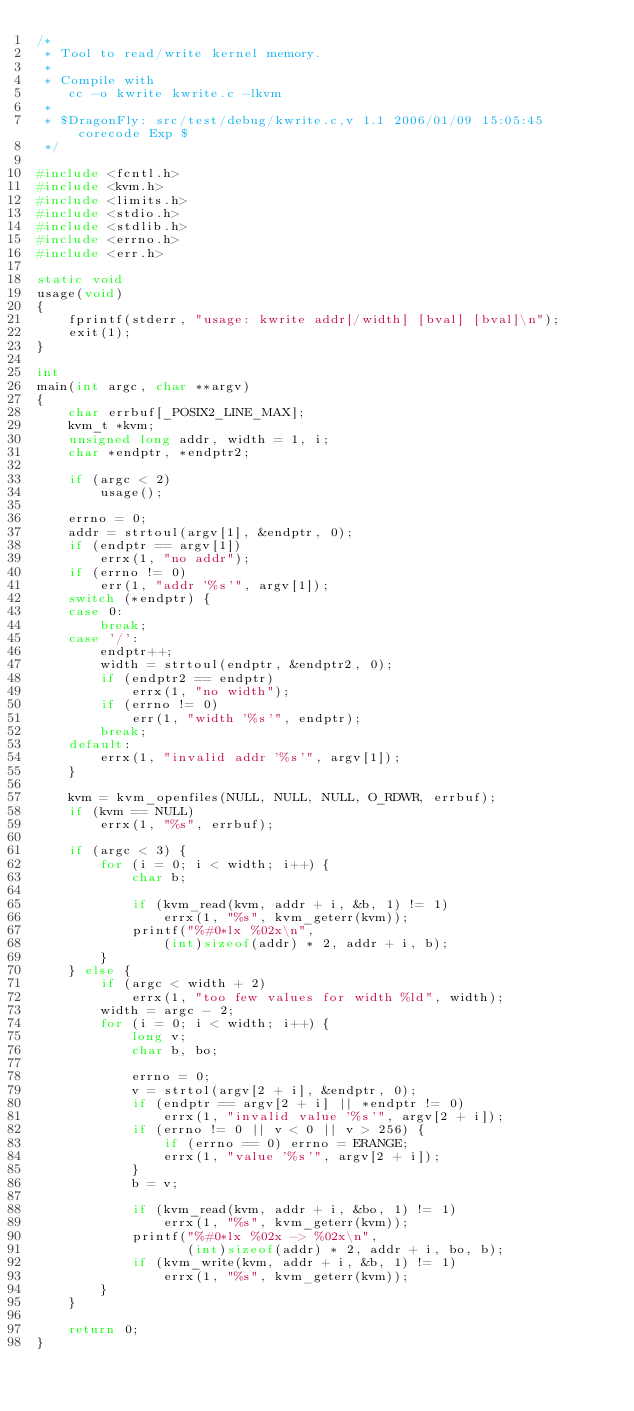<code> <loc_0><loc_0><loc_500><loc_500><_C_>/*
 * Tool to read/write kernel memory.
 *
 * Compile with
	cc -o kwrite kwrite.c -lkvm
 *
 * $DragonFly: src/test/debug/kwrite.c,v 1.1 2006/01/09 15:05:45 corecode Exp $
 */

#include <fcntl.h>
#include <kvm.h>
#include <limits.h>
#include <stdio.h>
#include <stdlib.h>
#include <errno.h>
#include <err.h>

static void
usage(void)
{
	fprintf(stderr, "usage: kwrite addr[/width] [bval] [bval]\n");
	exit(1);
}

int
main(int argc, char **argv)
{
	char errbuf[_POSIX2_LINE_MAX];
	kvm_t *kvm;
	unsigned long addr, width = 1, i;
	char *endptr, *endptr2;

	if (argc < 2)
		usage();

	errno = 0;
	addr = strtoul(argv[1], &endptr, 0);
	if (endptr == argv[1])
		errx(1, "no addr");
	if (errno != 0)
		err(1, "addr '%s'", argv[1]);
	switch (*endptr) {
	case 0:
		break;
	case '/':
		endptr++;
		width = strtoul(endptr, &endptr2, 0);
		if (endptr2 == endptr)
			errx(1, "no width");
		if (errno != 0)
			err(1, "width '%s'", endptr);
		break;
	default:
		errx(1, "invalid addr '%s'", argv[1]);
	}

	kvm = kvm_openfiles(NULL, NULL, NULL, O_RDWR, errbuf);
	if (kvm == NULL)
		errx(1, "%s", errbuf);

	if (argc < 3) {
		for (i = 0; i < width; i++) {
			char b;

			if (kvm_read(kvm, addr + i, &b, 1) != 1)
				errx(1, "%s", kvm_geterr(kvm));
			printf("%#0*lx %02x\n",
				(int)sizeof(addr) * 2, addr + i, b);
		}
	} else {
		if (argc < width + 2)
			errx(1, "too few values for width %ld", width);
		width = argc - 2;
		for (i = 0; i < width; i++) {
			long v;
			char b, bo;

			errno = 0;
			v = strtol(argv[2 + i], &endptr, 0);
			if (endptr == argv[2 + i] || *endptr != 0)
				errx(1, "invalid value '%s'", argv[2 + i]);
			if (errno != 0 || v < 0 || v > 256) {
				if (errno == 0) errno = ERANGE;
				errx(1, "value '%s'", argv[2 + i]);
			}
			b = v;

			if (kvm_read(kvm, addr + i, &bo, 1) != 1)
				errx(1, "%s", kvm_geterr(kvm));
			printf("%#0*lx %02x -> %02x\n",
			       (int)sizeof(addr) * 2, addr + i, bo, b);
			if (kvm_write(kvm, addr + i, &b, 1) != 1)
				errx(1, "%s", kvm_geterr(kvm));
		}
	}

	return 0;
}
</code> 